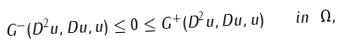Convert formula to latex. <formula><loc_0><loc_0><loc_500><loc_500>G ^ { - } ( D ^ { 2 } u , D u , u ) \leq 0 \leq G ^ { + } ( D ^ { 2 } u , D u , u ) \quad i n \ \Omega ,</formula> 